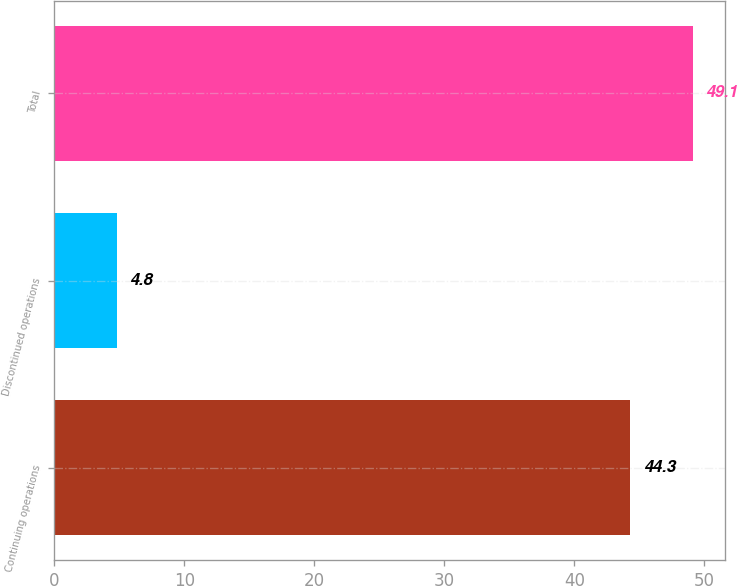Convert chart to OTSL. <chart><loc_0><loc_0><loc_500><loc_500><bar_chart><fcel>Continuing operations<fcel>Discontinued operations<fcel>Total<nl><fcel>44.3<fcel>4.8<fcel>49.1<nl></chart> 